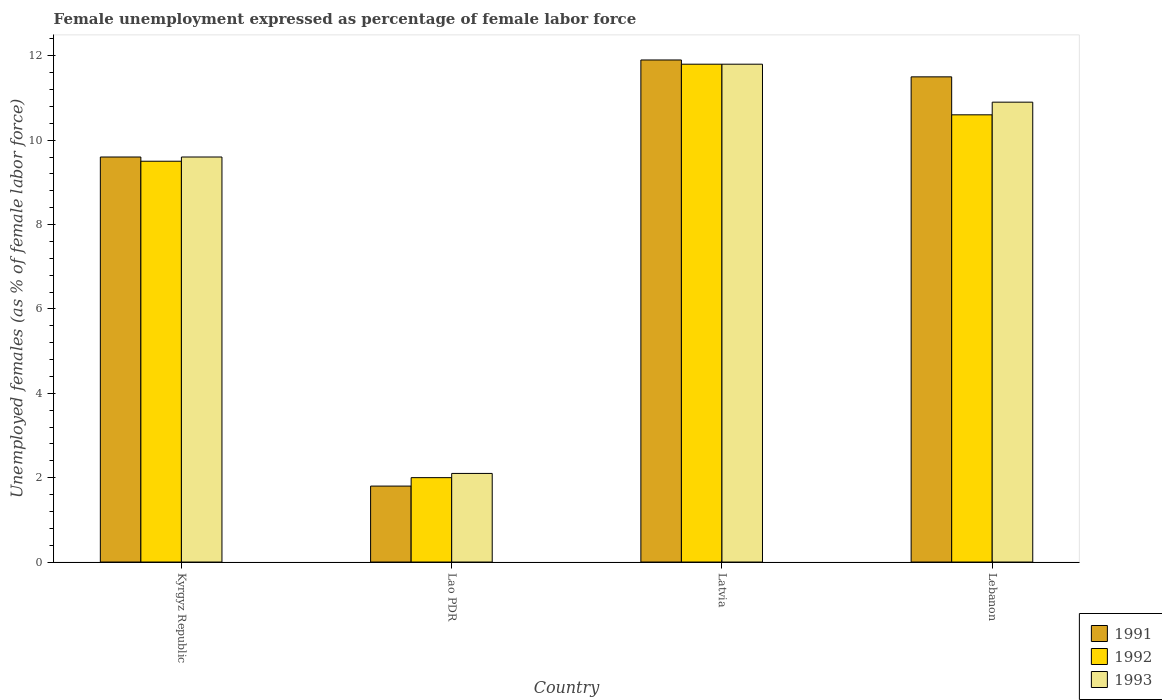How many different coloured bars are there?
Your answer should be very brief. 3. Are the number of bars per tick equal to the number of legend labels?
Ensure brevity in your answer.  Yes. Are the number of bars on each tick of the X-axis equal?
Your response must be concise. Yes. How many bars are there on the 1st tick from the right?
Keep it short and to the point. 3. What is the label of the 1st group of bars from the left?
Offer a very short reply. Kyrgyz Republic. In how many cases, is the number of bars for a given country not equal to the number of legend labels?
Offer a very short reply. 0. What is the unemployment in females in in 1991 in Latvia?
Your response must be concise. 11.9. Across all countries, what is the maximum unemployment in females in in 1992?
Keep it short and to the point. 11.8. Across all countries, what is the minimum unemployment in females in in 1992?
Make the answer very short. 2. In which country was the unemployment in females in in 1992 maximum?
Your response must be concise. Latvia. In which country was the unemployment in females in in 1991 minimum?
Your answer should be very brief. Lao PDR. What is the total unemployment in females in in 1993 in the graph?
Offer a very short reply. 34.4. What is the difference between the unemployment in females in in 1991 in Kyrgyz Republic and that in Lebanon?
Keep it short and to the point. -1.9. What is the difference between the unemployment in females in in 1991 in Lebanon and the unemployment in females in in 1992 in Lao PDR?
Your answer should be compact. 9.5. What is the average unemployment in females in in 1991 per country?
Make the answer very short. 8.7. What is the difference between the unemployment in females in of/in 1993 and unemployment in females in of/in 1992 in Lao PDR?
Your answer should be compact. 0.1. In how many countries, is the unemployment in females in in 1993 greater than 8.4 %?
Make the answer very short. 3. What is the ratio of the unemployment in females in in 1992 in Lao PDR to that in Latvia?
Give a very brief answer. 0.17. Is the unemployment in females in in 1993 in Kyrgyz Republic less than that in Lao PDR?
Your answer should be very brief. No. What is the difference between the highest and the second highest unemployment in females in in 1991?
Your answer should be compact. 1.9. What is the difference between the highest and the lowest unemployment in females in in 1993?
Offer a terse response. 9.7. In how many countries, is the unemployment in females in in 1992 greater than the average unemployment in females in in 1992 taken over all countries?
Provide a short and direct response. 3. What does the 2nd bar from the left in Kyrgyz Republic represents?
Your response must be concise. 1992. How many bars are there?
Ensure brevity in your answer.  12. Are all the bars in the graph horizontal?
Your answer should be very brief. No. How many countries are there in the graph?
Provide a short and direct response. 4. What is the difference between two consecutive major ticks on the Y-axis?
Offer a very short reply. 2. Are the values on the major ticks of Y-axis written in scientific E-notation?
Provide a succinct answer. No. Does the graph contain any zero values?
Your answer should be compact. No. Does the graph contain grids?
Your answer should be compact. No. Where does the legend appear in the graph?
Offer a very short reply. Bottom right. How many legend labels are there?
Your response must be concise. 3. How are the legend labels stacked?
Give a very brief answer. Vertical. What is the title of the graph?
Offer a very short reply. Female unemployment expressed as percentage of female labor force. Does "1977" appear as one of the legend labels in the graph?
Offer a terse response. No. What is the label or title of the Y-axis?
Offer a very short reply. Unemployed females (as % of female labor force). What is the Unemployed females (as % of female labor force) of 1991 in Kyrgyz Republic?
Provide a short and direct response. 9.6. What is the Unemployed females (as % of female labor force) in 1993 in Kyrgyz Republic?
Provide a succinct answer. 9.6. What is the Unemployed females (as % of female labor force) in 1991 in Lao PDR?
Give a very brief answer. 1.8. What is the Unemployed females (as % of female labor force) in 1992 in Lao PDR?
Keep it short and to the point. 2. What is the Unemployed females (as % of female labor force) of 1993 in Lao PDR?
Ensure brevity in your answer.  2.1. What is the Unemployed females (as % of female labor force) of 1991 in Latvia?
Offer a terse response. 11.9. What is the Unemployed females (as % of female labor force) of 1992 in Latvia?
Provide a succinct answer. 11.8. What is the Unemployed females (as % of female labor force) in 1993 in Latvia?
Keep it short and to the point. 11.8. What is the Unemployed females (as % of female labor force) of 1991 in Lebanon?
Offer a very short reply. 11.5. What is the Unemployed females (as % of female labor force) in 1992 in Lebanon?
Provide a succinct answer. 10.6. What is the Unemployed females (as % of female labor force) of 1993 in Lebanon?
Provide a short and direct response. 10.9. Across all countries, what is the maximum Unemployed females (as % of female labor force) of 1991?
Your answer should be very brief. 11.9. Across all countries, what is the maximum Unemployed females (as % of female labor force) in 1992?
Make the answer very short. 11.8. Across all countries, what is the maximum Unemployed females (as % of female labor force) of 1993?
Your response must be concise. 11.8. Across all countries, what is the minimum Unemployed females (as % of female labor force) of 1991?
Keep it short and to the point. 1.8. Across all countries, what is the minimum Unemployed females (as % of female labor force) of 1993?
Keep it short and to the point. 2.1. What is the total Unemployed females (as % of female labor force) in 1991 in the graph?
Keep it short and to the point. 34.8. What is the total Unemployed females (as % of female labor force) of 1992 in the graph?
Offer a very short reply. 33.9. What is the total Unemployed females (as % of female labor force) of 1993 in the graph?
Make the answer very short. 34.4. What is the difference between the Unemployed females (as % of female labor force) of 1991 in Kyrgyz Republic and that in Lao PDR?
Your answer should be very brief. 7.8. What is the difference between the Unemployed females (as % of female labor force) of 1993 in Kyrgyz Republic and that in Lao PDR?
Your response must be concise. 7.5. What is the difference between the Unemployed females (as % of female labor force) in 1991 in Kyrgyz Republic and that in Latvia?
Offer a very short reply. -2.3. What is the difference between the Unemployed females (as % of female labor force) of 1992 in Kyrgyz Republic and that in Latvia?
Ensure brevity in your answer.  -2.3. What is the difference between the Unemployed females (as % of female labor force) in 1993 in Kyrgyz Republic and that in Lebanon?
Provide a succinct answer. -1.3. What is the difference between the Unemployed females (as % of female labor force) of 1991 in Lao PDR and that in Latvia?
Offer a very short reply. -10.1. What is the difference between the Unemployed females (as % of female labor force) in 1991 in Lao PDR and that in Lebanon?
Your answer should be very brief. -9.7. What is the difference between the Unemployed females (as % of female labor force) in 1992 in Lao PDR and that in Lebanon?
Keep it short and to the point. -8.6. What is the difference between the Unemployed females (as % of female labor force) of 1993 in Lao PDR and that in Lebanon?
Your answer should be very brief. -8.8. What is the difference between the Unemployed females (as % of female labor force) in 1991 in Latvia and that in Lebanon?
Provide a succinct answer. 0.4. What is the difference between the Unemployed females (as % of female labor force) in 1991 in Kyrgyz Republic and the Unemployed females (as % of female labor force) in 1992 in Lao PDR?
Offer a very short reply. 7.6. What is the difference between the Unemployed females (as % of female labor force) in 1991 in Kyrgyz Republic and the Unemployed females (as % of female labor force) in 1993 in Lao PDR?
Your answer should be very brief. 7.5. What is the difference between the Unemployed females (as % of female labor force) in 1992 in Kyrgyz Republic and the Unemployed females (as % of female labor force) in 1993 in Lao PDR?
Keep it short and to the point. 7.4. What is the difference between the Unemployed females (as % of female labor force) in 1991 in Kyrgyz Republic and the Unemployed females (as % of female labor force) in 1993 in Lebanon?
Provide a succinct answer. -1.3. What is the difference between the Unemployed females (as % of female labor force) of 1992 in Kyrgyz Republic and the Unemployed females (as % of female labor force) of 1993 in Lebanon?
Make the answer very short. -1.4. What is the difference between the Unemployed females (as % of female labor force) of 1991 in Lao PDR and the Unemployed females (as % of female labor force) of 1993 in Latvia?
Offer a very short reply. -10. What is the difference between the Unemployed females (as % of female labor force) of 1992 in Lao PDR and the Unemployed females (as % of female labor force) of 1993 in Latvia?
Keep it short and to the point. -9.8. What is the difference between the Unemployed females (as % of female labor force) in 1992 in Lao PDR and the Unemployed females (as % of female labor force) in 1993 in Lebanon?
Ensure brevity in your answer.  -8.9. What is the difference between the Unemployed females (as % of female labor force) of 1991 in Latvia and the Unemployed females (as % of female labor force) of 1993 in Lebanon?
Provide a short and direct response. 1. What is the average Unemployed females (as % of female labor force) in 1991 per country?
Your response must be concise. 8.7. What is the average Unemployed females (as % of female labor force) in 1992 per country?
Ensure brevity in your answer.  8.47. What is the average Unemployed females (as % of female labor force) of 1993 per country?
Offer a very short reply. 8.6. What is the difference between the Unemployed females (as % of female labor force) in 1991 and Unemployed females (as % of female labor force) in 1993 in Kyrgyz Republic?
Give a very brief answer. 0. What is the difference between the Unemployed females (as % of female labor force) in 1991 and Unemployed females (as % of female labor force) in 1993 in Lao PDR?
Keep it short and to the point. -0.3. What is the difference between the Unemployed females (as % of female labor force) of 1991 and Unemployed females (as % of female labor force) of 1993 in Latvia?
Make the answer very short. 0.1. What is the difference between the Unemployed females (as % of female labor force) of 1991 and Unemployed females (as % of female labor force) of 1993 in Lebanon?
Provide a short and direct response. 0.6. What is the ratio of the Unemployed females (as % of female labor force) in 1991 in Kyrgyz Republic to that in Lao PDR?
Provide a short and direct response. 5.33. What is the ratio of the Unemployed females (as % of female labor force) in 1992 in Kyrgyz Republic to that in Lao PDR?
Your response must be concise. 4.75. What is the ratio of the Unemployed females (as % of female labor force) in 1993 in Kyrgyz Republic to that in Lao PDR?
Ensure brevity in your answer.  4.57. What is the ratio of the Unemployed females (as % of female labor force) in 1991 in Kyrgyz Republic to that in Latvia?
Offer a terse response. 0.81. What is the ratio of the Unemployed females (as % of female labor force) in 1992 in Kyrgyz Republic to that in Latvia?
Provide a short and direct response. 0.81. What is the ratio of the Unemployed females (as % of female labor force) of 1993 in Kyrgyz Republic to that in Latvia?
Keep it short and to the point. 0.81. What is the ratio of the Unemployed females (as % of female labor force) of 1991 in Kyrgyz Republic to that in Lebanon?
Your answer should be compact. 0.83. What is the ratio of the Unemployed females (as % of female labor force) in 1992 in Kyrgyz Republic to that in Lebanon?
Provide a succinct answer. 0.9. What is the ratio of the Unemployed females (as % of female labor force) of 1993 in Kyrgyz Republic to that in Lebanon?
Keep it short and to the point. 0.88. What is the ratio of the Unemployed females (as % of female labor force) in 1991 in Lao PDR to that in Latvia?
Ensure brevity in your answer.  0.15. What is the ratio of the Unemployed females (as % of female labor force) in 1992 in Lao PDR to that in Latvia?
Your answer should be compact. 0.17. What is the ratio of the Unemployed females (as % of female labor force) of 1993 in Lao PDR to that in Latvia?
Provide a short and direct response. 0.18. What is the ratio of the Unemployed females (as % of female labor force) in 1991 in Lao PDR to that in Lebanon?
Provide a short and direct response. 0.16. What is the ratio of the Unemployed females (as % of female labor force) in 1992 in Lao PDR to that in Lebanon?
Offer a very short reply. 0.19. What is the ratio of the Unemployed females (as % of female labor force) of 1993 in Lao PDR to that in Lebanon?
Your response must be concise. 0.19. What is the ratio of the Unemployed females (as % of female labor force) in 1991 in Latvia to that in Lebanon?
Your answer should be compact. 1.03. What is the ratio of the Unemployed females (as % of female labor force) in 1992 in Latvia to that in Lebanon?
Provide a succinct answer. 1.11. What is the ratio of the Unemployed females (as % of female labor force) of 1993 in Latvia to that in Lebanon?
Offer a terse response. 1.08. What is the difference between the highest and the second highest Unemployed females (as % of female labor force) in 1991?
Provide a short and direct response. 0.4. What is the difference between the highest and the second highest Unemployed females (as % of female labor force) of 1992?
Your response must be concise. 1.2. What is the difference between the highest and the lowest Unemployed females (as % of female labor force) of 1991?
Make the answer very short. 10.1. What is the difference between the highest and the lowest Unemployed females (as % of female labor force) of 1993?
Offer a very short reply. 9.7. 